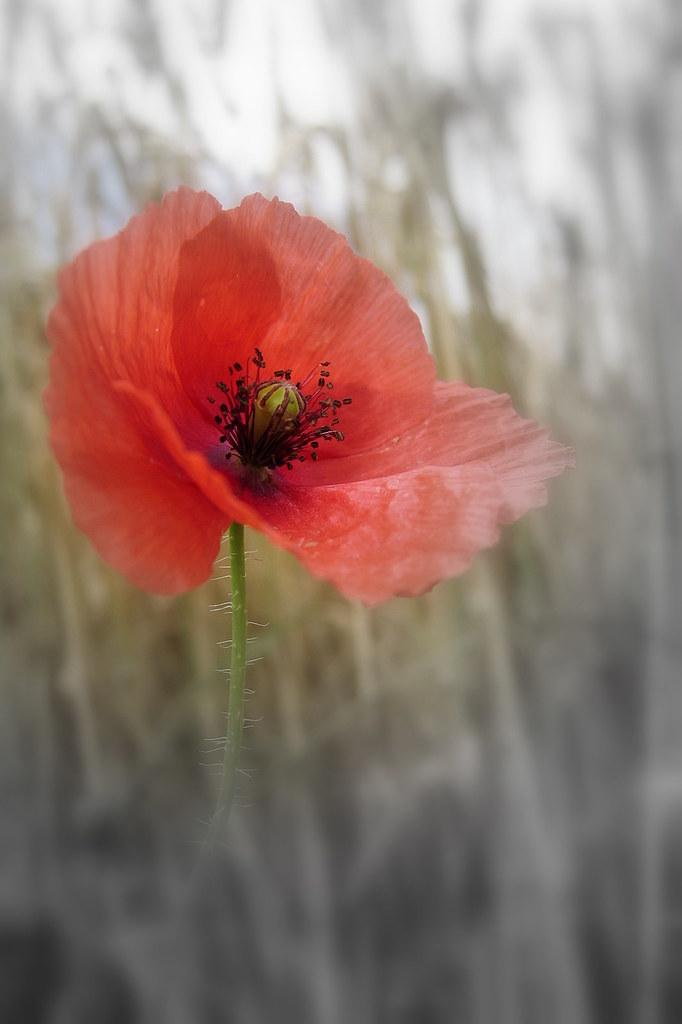What type of flower is the main subject of the image? There is a red flower in the image. What color are the pistils of the flower? The flower has black pistils. How would you describe the background of the image? The background of the image is blurry. What is the primary focus of the image? The flower is the main focus of the image. What type of tank can be seen in the background of the image? There is no tank present in the image; the background is blurry and only the red flower with black pistils is the main focus. Is there a cart carrying the flower in the image? There is no cart present in the image; the flower is the main focus and appears to be standing on its own. 